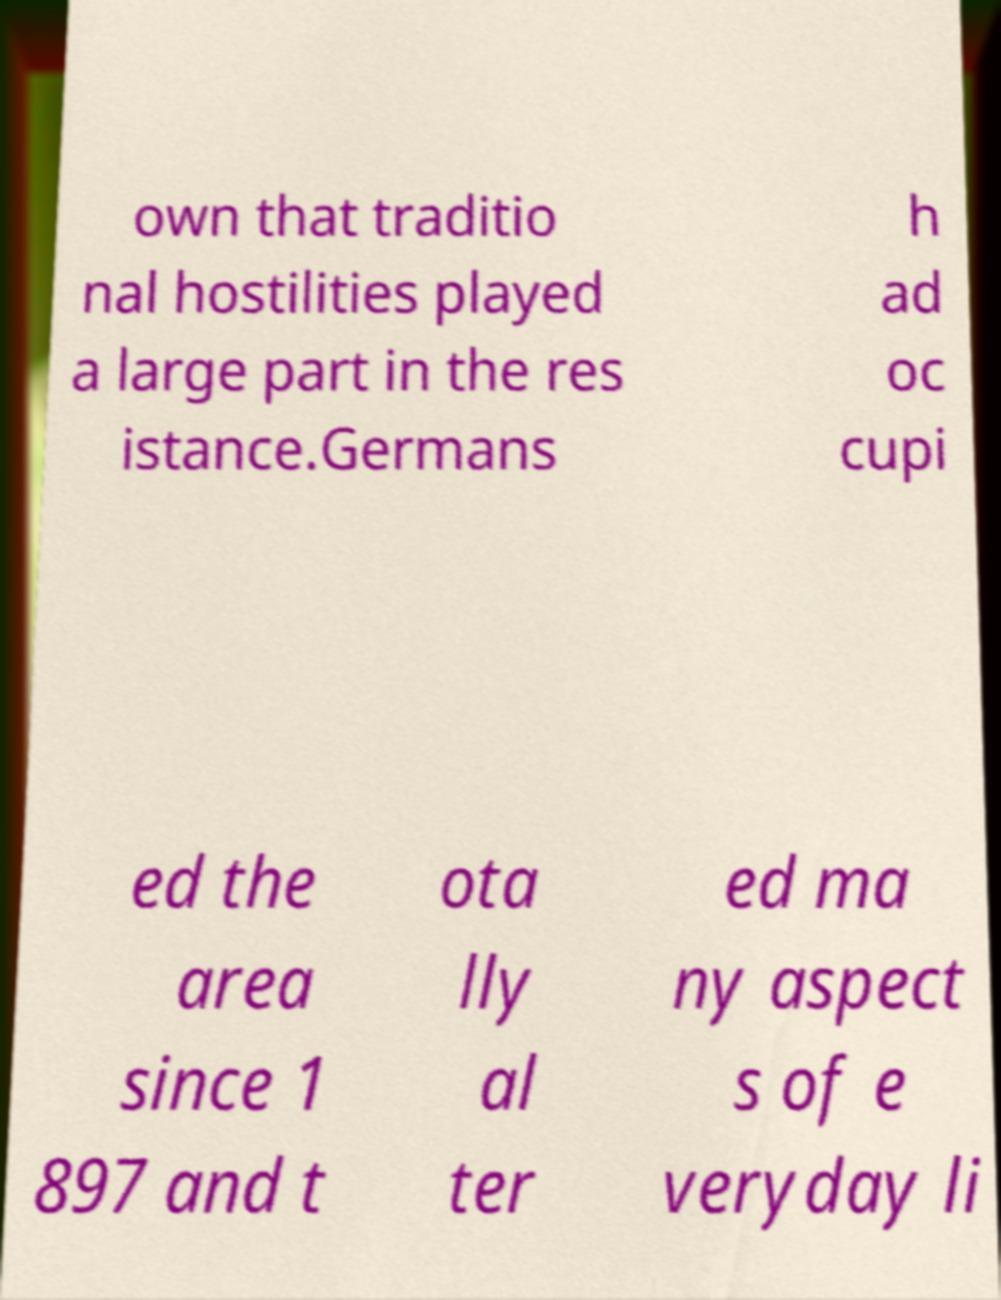Could you extract and type out the text from this image? own that traditio nal hostilities played a large part in the res istance.Germans h ad oc cupi ed the area since 1 897 and t ota lly al ter ed ma ny aspect s of e veryday li 